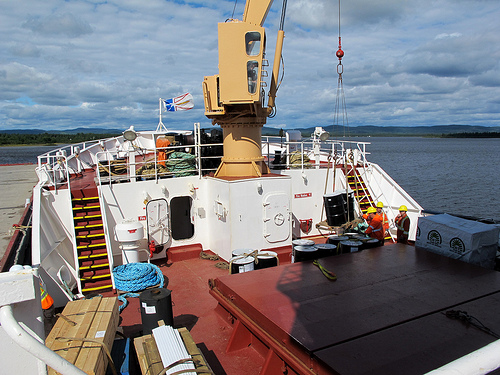<image>
Is there a sky behind the ship? Yes. From this viewpoint, the sky is positioned behind the ship, with the ship partially or fully occluding the sky. Is the people to the right of the stairs? Yes. From this viewpoint, the people is positioned to the right side relative to the stairs. 